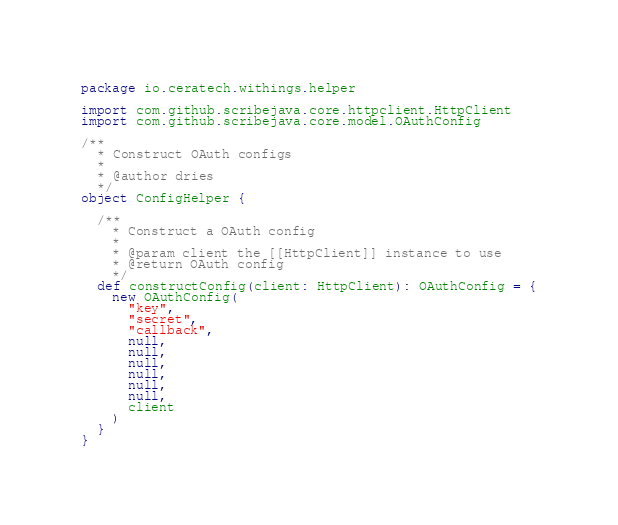Convert code to text. <code><loc_0><loc_0><loc_500><loc_500><_Scala_>package io.ceratech.withings.helper

import com.github.scribejava.core.httpclient.HttpClient
import com.github.scribejava.core.model.OAuthConfig

/**
  * Construct OAuth configs
  *
  * @author dries
  */
object ConfigHelper {

  /**
    * Construct a OAuth config
    *
    * @param client the [[HttpClient]] instance to use
    * @return OAuth config
    */
  def constructConfig(client: HttpClient): OAuthConfig = {
    new OAuthConfig(
      "key",
      "secret",
      "callback",
      null,
      null,
      null,
      null,
      null,
      null,
      client
    )
  }
}
</code> 